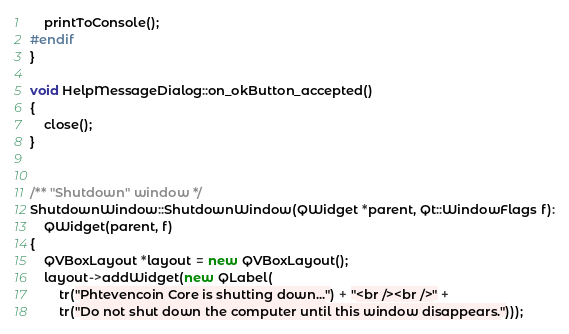Convert code to text. <code><loc_0><loc_0><loc_500><loc_500><_C++_>    printToConsole();
#endif
}

void HelpMessageDialog::on_okButton_accepted()
{
    close();
}


/** "Shutdown" window */
ShutdownWindow::ShutdownWindow(QWidget *parent, Qt::WindowFlags f):
    QWidget(parent, f)
{
    QVBoxLayout *layout = new QVBoxLayout();
    layout->addWidget(new QLabel(
        tr("Phtevencoin Core is shutting down...") + "<br /><br />" +
        tr("Do not shut down the computer until this window disappears.")));</code> 